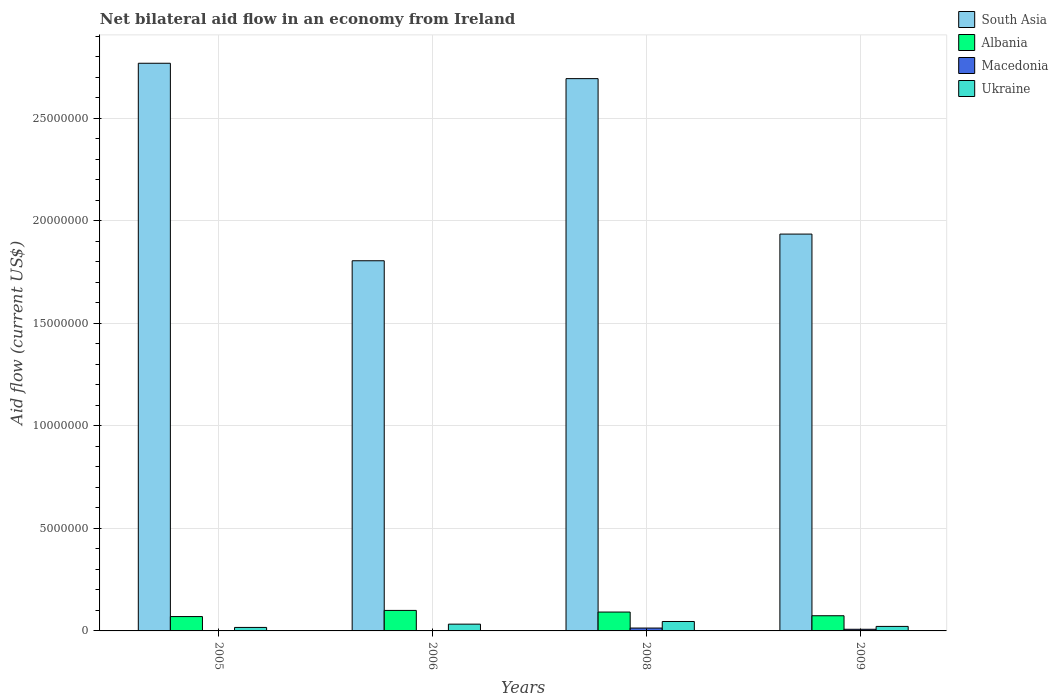Are the number of bars on each tick of the X-axis equal?
Offer a terse response. Yes. How many bars are there on the 4th tick from the left?
Your answer should be compact. 4. In how many cases, is the number of bars for a given year not equal to the number of legend labels?
Make the answer very short. 0. What is the net bilateral aid flow in Albania in 2009?
Offer a very short reply. 7.40e+05. Across all years, what is the maximum net bilateral aid flow in Ukraine?
Your response must be concise. 4.60e+05. In which year was the net bilateral aid flow in Albania maximum?
Ensure brevity in your answer.  2006. What is the total net bilateral aid flow in Albania in the graph?
Offer a very short reply. 3.36e+06. What is the difference between the net bilateral aid flow in South Asia in 2005 and the net bilateral aid flow in Albania in 2009?
Make the answer very short. 2.69e+07. What is the average net bilateral aid flow in Albania per year?
Keep it short and to the point. 8.40e+05. In the year 2008, what is the difference between the net bilateral aid flow in South Asia and net bilateral aid flow in Ukraine?
Offer a terse response. 2.65e+07. What is the ratio of the net bilateral aid flow in Ukraine in 2006 to that in 2008?
Give a very brief answer. 0.72. Is the difference between the net bilateral aid flow in South Asia in 2005 and 2008 greater than the difference between the net bilateral aid flow in Ukraine in 2005 and 2008?
Offer a terse response. Yes. What is the difference between the highest and the second highest net bilateral aid flow in Ukraine?
Make the answer very short. 1.30e+05. In how many years, is the net bilateral aid flow in Ukraine greater than the average net bilateral aid flow in Ukraine taken over all years?
Your response must be concise. 2. Is the sum of the net bilateral aid flow in Albania in 2005 and 2006 greater than the maximum net bilateral aid flow in Ukraine across all years?
Your response must be concise. Yes. What does the 1st bar from the left in 2006 represents?
Your response must be concise. South Asia. What does the 2nd bar from the right in 2005 represents?
Your answer should be compact. Macedonia. How many bars are there?
Offer a terse response. 16. Are all the bars in the graph horizontal?
Ensure brevity in your answer.  No. How many years are there in the graph?
Provide a short and direct response. 4. What is the difference between two consecutive major ticks on the Y-axis?
Offer a terse response. 5.00e+06. Are the values on the major ticks of Y-axis written in scientific E-notation?
Keep it short and to the point. No. Does the graph contain grids?
Ensure brevity in your answer.  Yes. Where does the legend appear in the graph?
Offer a very short reply. Top right. How many legend labels are there?
Your answer should be compact. 4. What is the title of the graph?
Provide a succinct answer. Net bilateral aid flow in an economy from Ireland. What is the Aid flow (current US$) of South Asia in 2005?
Your answer should be compact. 2.77e+07. What is the Aid flow (current US$) of Ukraine in 2005?
Keep it short and to the point. 1.70e+05. What is the Aid flow (current US$) of South Asia in 2006?
Your answer should be compact. 1.80e+07. What is the Aid flow (current US$) in Ukraine in 2006?
Ensure brevity in your answer.  3.30e+05. What is the Aid flow (current US$) in South Asia in 2008?
Your answer should be very brief. 2.69e+07. What is the Aid flow (current US$) in Albania in 2008?
Your answer should be compact. 9.20e+05. What is the Aid flow (current US$) in South Asia in 2009?
Offer a terse response. 1.94e+07. What is the Aid flow (current US$) of Albania in 2009?
Offer a terse response. 7.40e+05. Across all years, what is the maximum Aid flow (current US$) in South Asia?
Offer a very short reply. 2.77e+07. Across all years, what is the maximum Aid flow (current US$) in Albania?
Make the answer very short. 1.00e+06. Across all years, what is the maximum Aid flow (current US$) in Macedonia?
Keep it short and to the point. 1.40e+05. Across all years, what is the maximum Aid flow (current US$) in Ukraine?
Offer a terse response. 4.60e+05. Across all years, what is the minimum Aid flow (current US$) in South Asia?
Your response must be concise. 1.80e+07. Across all years, what is the minimum Aid flow (current US$) in Ukraine?
Keep it short and to the point. 1.70e+05. What is the total Aid flow (current US$) of South Asia in the graph?
Give a very brief answer. 9.20e+07. What is the total Aid flow (current US$) in Albania in the graph?
Offer a very short reply. 3.36e+06. What is the total Aid flow (current US$) of Ukraine in the graph?
Provide a succinct answer. 1.18e+06. What is the difference between the Aid flow (current US$) of South Asia in 2005 and that in 2006?
Ensure brevity in your answer.  9.63e+06. What is the difference between the Aid flow (current US$) of Albania in 2005 and that in 2006?
Your response must be concise. -3.00e+05. What is the difference between the Aid flow (current US$) of Macedonia in 2005 and that in 2006?
Your answer should be compact. -10000. What is the difference between the Aid flow (current US$) of Ukraine in 2005 and that in 2006?
Offer a very short reply. -1.60e+05. What is the difference between the Aid flow (current US$) of South Asia in 2005 and that in 2008?
Your answer should be very brief. 7.50e+05. What is the difference between the Aid flow (current US$) in Macedonia in 2005 and that in 2008?
Your answer should be very brief. -1.30e+05. What is the difference between the Aid flow (current US$) of South Asia in 2005 and that in 2009?
Keep it short and to the point. 8.33e+06. What is the difference between the Aid flow (current US$) in Macedonia in 2005 and that in 2009?
Your answer should be compact. -7.00e+04. What is the difference between the Aid flow (current US$) of South Asia in 2006 and that in 2008?
Your answer should be compact. -8.88e+06. What is the difference between the Aid flow (current US$) in Albania in 2006 and that in 2008?
Provide a short and direct response. 8.00e+04. What is the difference between the Aid flow (current US$) in Ukraine in 2006 and that in 2008?
Offer a terse response. -1.30e+05. What is the difference between the Aid flow (current US$) of South Asia in 2006 and that in 2009?
Provide a succinct answer. -1.30e+06. What is the difference between the Aid flow (current US$) in Albania in 2006 and that in 2009?
Provide a succinct answer. 2.60e+05. What is the difference between the Aid flow (current US$) in Macedonia in 2006 and that in 2009?
Give a very brief answer. -6.00e+04. What is the difference between the Aid flow (current US$) in Ukraine in 2006 and that in 2009?
Keep it short and to the point. 1.10e+05. What is the difference between the Aid flow (current US$) of South Asia in 2008 and that in 2009?
Ensure brevity in your answer.  7.58e+06. What is the difference between the Aid flow (current US$) in Albania in 2008 and that in 2009?
Keep it short and to the point. 1.80e+05. What is the difference between the Aid flow (current US$) in Macedonia in 2008 and that in 2009?
Offer a terse response. 6.00e+04. What is the difference between the Aid flow (current US$) in Ukraine in 2008 and that in 2009?
Offer a very short reply. 2.40e+05. What is the difference between the Aid flow (current US$) in South Asia in 2005 and the Aid flow (current US$) in Albania in 2006?
Your answer should be compact. 2.67e+07. What is the difference between the Aid flow (current US$) in South Asia in 2005 and the Aid flow (current US$) in Macedonia in 2006?
Provide a succinct answer. 2.77e+07. What is the difference between the Aid flow (current US$) of South Asia in 2005 and the Aid flow (current US$) of Ukraine in 2006?
Your answer should be compact. 2.74e+07. What is the difference between the Aid flow (current US$) of Albania in 2005 and the Aid flow (current US$) of Macedonia in 2006?
Keep it short and to the point. 6.80e+05. What is the difference between the Aid flow (current US$) in Macedonia in 2005 and the Aid flow (current US$) in Ukraine in 2006?
Provide a short and direct response. -3.20e+05. What is the difference between the Aid flow (current US$) of South Asia in 2005 and the Aid flow (current US$) of Albania in 2008?
Keep it short and to the point. 2.68e+07. What is the difference between the Aid flow (current US$) in South Asia in 2005 and the Aid flow (current US$) in Macedonia in 2008?
Ensure brevity in your answer.  2.75e+07. What is the difference between the Aid flow (current US$) in South Asia in 2005 and the Aid flow (current US$) in Ukraine in 2008?
Your answer should be very brief. 2.72e+07. What is the difference between the Aid flow (current US$) of Albania in 2005 and the Aid flow (current US$) of Macedonia in 2008?
Make the answer very short. 5.60e+05. What is the difference between the Aid flow (current US$) of Macedonia in 2005 and the Aid flow (current US$) of Ukraine in 2008?
Your answer should be very brief. -4.50e+05. What is the difference between the Aid flow (current US$) of South Asia in 2005 and the Aid flow (current US$) of Albania in 2009?
Keep it short and to the point. 2.69e+07. What is the difference between the Aid flow (current US$) in South Asia in 2005 and the Aid flow (current US$) in Macedonia in 2009?
Your response must be concise. 2.76e+07. What is the difference between the Aid flow (current US$) in South Asia in 2005 and the Aid flow (current US$) in Ukraine in 2009?
Your answer should be compact. 2.75e+07. What is the difference between the Aid flow (current US$) in Albania in 2005 and the Aid flow (current US$) in Macedonia in 2009?
Make the answer very short. 6.20e+05. What is the difference between the Aid flow (current US$) in Albania in 2005 and the Aid flow (current US$) in Ukraine in 2009?
Make the answer very short. 4.80e+05. What is the difference between the Aid flow (current US$) of Macedonia in 2005 and the Aid flow (current US$) of Ukraine in 2009?
Provide a short and direct response. -2.10e+05. What is the difference between the Aid flow (current US$) in South Asia in 2006 and the Aid flow (current US$) in Albania in 2008?
Give a very brief answer. 1.71e+07. What is the difference between the Aid flow (current US$) of South Asia in 2006 and the Aid flow (current US$) of Macedonia in 2008?
Keep it short and to the point. 1.79e+07. What is the difference between the Aid flow (current US$) in South Asia in 2006 and the Aid flow (current US$) in Ukraine in 2008?
Ensure brevity in your answer.  1.76e+07. What is the difference between the Aid flow (current US$) of Albania in 2006 and the Aid flow (current US$) of Macedonia in 2008?
Keep it short and to the point. 8.60e+05. What is the difference between the Aid flow (current US$) of Albania in 2006 and the Aid flow (current US$) of Ukraine in 2008?
Your answer should be compact. 5.40e+05. What is the difference between the Aid flow (current US$) of Macedonia in 2006 and the Aid flow (current US$) of Ukraine in 2008?
Offer a terse response. -4.40e+05. What is the difference between the Aid flow (current US$) of South Asia in 2006 and the Aid flow (current US$) of Albania in 2009?
Your answer should be compact. 1.73e+07. What is the difference between the Aid flow (current US$) in South Asia in 2006 and the Aid flow (current US$) in Macedonia in 2009?
Offer a terse response. 1.80e+07. What is the difference between the Aid flow (current US$) of South Asia in 2006 and the Aid flow (current US$) of Ukraine in 2009?
Give a very brief answer. 1.78e+07. What is the difference between the Aid flow (current US$) in Albania in 2006 and the Aid flow (current US$) in Macedonia in 2009?
Make the answer very short. 9.20e+05. What is the difference between the Aid flow (current US$) in Albania in 2006 and the Aid flow (current US$) in Ukraine in 2009?
Keep it short and to the point. 7.80e+05. What is the difference between the Aid flow (current US$) in South Asia in 2008 and the Aid flow (current US$) in Albania in 2009?
Give a very brief answer. 2.62e+07. What is the difference between the Aid flow (current US$) in South Asia in 2008 and the Aid flow (current US$) in Macedonia in 2009?
Ensure brevity in your answer.  2.68e+07. What is the difference between the Aid flow (current US$) in South Asia in 2008 and the Aid flow (current US$) in Ukraine in 2009?
Provide a succinct answer. 2.67e+07. What is the difference between the Aid flow (current US$) of Albania in 2008 and the Aid flow (current US$) of Macedonia in 2009?
Your answer should be compact. 8.40e+05. What is the difference between the Aid flow (current US$) of Macedonia in 2008 and the Aid flow (current US$) of Ukraine in 2009?
Provide a short and direct response. -8.00e+04. What is the average Aid flow (current US$) in South Asia per year?
Your answer should be very brief. 2.30e+07. What is the average Aid flow (current US$) in Albania per year?
Make the answer very short. 8.40e+05. What is the average Aid flow (current US$) in Macedonia per year?
Your answer should be very brief. 6.25e+04. What is the average Aid flow (current US$) in Ukraine per year?
Offer a terse response. 2.95e+05. In the year 2005, what is the difference between the Aid flow (current US$) in South Asia and Aid flow (current US$) in Albania?
Your response must be concise. 2.70e+07. In the year 2005, what is the difference between the Aid flow (current US$) of South Asia and Aid flow (current US$) of Macedonia?
Keep it short and to the point. 2.77e+07. In the year 2005, what is the difference between the Aid flow (current US$) of South Asia and Aid flow (current US$) of Ukraine?
Offer a terse response. 2.75e+07. In the year 2005, what is the difference between the Aid flow (current US$) in Albania and Aid flow (current US$) in Macedonia?
Your answer should be compact. 6.90e+05. In the year 2005, what is the difference between the Aid flow (current US$) in Albania and Aid flow (current US$) in Ukraine?
Offer a terse response. 5.30e+05. In the year 2005, what is the difference between the Aid flow (current US$) in Macedonia and Aid flow (current US$) in Ukraine?
Give a very brief answer. -1.60e+05. In the year 2006, what is the difference between the Aid flow (current US$) in South Asia and Aid flow (current US$) in Albania?
Provide a succinct answer. 1.70e+07. In the year 2006, what is the difference between the Aid flow (current US$) in South Asia and Aid flow (current US$) in Macedonia?
Keep it short and to the point. 1.80e+07. In the year 2006, what is the difference between the Aid flow (current US$) of South Asia and Aid flow (current US$) of Ukraine?
Offer a very short reply. 1.77e+07. In the year 2006, what is the difference between the Aid flow (current US$) in Albania and Aid flow (current US$) in Macedonia?
Provide a short and direct response. 9.80e+05. In the year 2006, what is the difference between the Aid flow (current US$) of Albania and Aid flow (current US$) of Ukraine?
Provide a short and direct response. 6.70e+05. In the year 2006, what is the difference between the Aid flow (current US$) in Macedonia and Aid flow (current US$) in Ukraine?
Make the answer very short. -3.10e+05. In the year 2008, what is the difference between the Aid flow (current US$) in South Asia and Aid flow (current US$) in Albania?
Your answer should be very brief. 2.60e+07. In the year 2008, what is the difference between the Aid flow (current US$) in South Asia and Aid flow (current US$) in Macedonia?
Ensure brevity in your answer.  2.68e+07. In the year 2008, what is the difference between the Aid flow (current US$) of South Asia and Aid flow (current US$) of Ukraine?
Give a very brief answer. 2.65e+07. In the year 2008, what is the difference between the Aid flow (current US$) in Albania and Aid flow (current US$) in Macedonia?
Offer a very short reply. 7.80e+05. In the year 2008, what is the difference between the Aid flow (current US$) in Macedonia and Aid flow (current US$) in Ukraine?
Provide a short and direct response. -3.20e+05. In the year 2009, what is the difference between the Aid flow (current US$) of South Asia and Aid flow (current US$) of Albania?
Your response must be concise. 1.86e+07. In the year 2009, what is the difference between the Aid flow (current US$) in South Asia and Aid flow (current US$) in Macedonia?
Your answer should be very brief. 1.93e+07. In the year 2009, what is the difference between the Aid flow (current US$) of South Asia and Aid flow (current US$) of Ukraine?
Provide a succinct answer. 1.91e+07. In the year 2009, what is the difference between the Aid flow (current US$) in Albania and Aid flow (current US$) in Ukraine?
Make the answer very short. 5.20e+05. In the year 2009, what is the difference between the Aid flow (current US$) in Macedonia and Aid flow (current US$) in Ukraine?
Provide a succinct answer. -1.40e+05. What is the ratio of the Aid flow (current US$) in South Asia in 2005 to that in 2006?
Offer a very short reply. 1.53. What is the ratio of the Aid flow (current US$) in Albania in 2005 to that in 2006?
Keep it short and to the point. 0.7. What is the ratio of the Aid flow (current US$) in Ukraine in 2005 to that in 2006?
Give a very brief answer. 0.52. What is the ratio of the Aid flow (current US$) in South Asia in 2005 to that in 2008?
Give a very brief answer. 1.03. What is the ratio of the Aid flow (current US$) in Albania in 2005 to that in 2008?
Your answer should be very brief. 0.76. What is the ratio of the Aid flow (current US$) in Macedonia in 2005 to that in 2008?
Ensure brevity in your answer.  0.07. What is the ratio of the Aid flow (current US$) in Ukraine in 2005 to that in 2008?
Provide a succinct answer. 0.37. What is the ratio of the Aid flow (current US$) of South Asia in 2005 to that in 2009?
Offer a terse response. 1.43. What is the ratio of the Aid flow (current US$) of Albania in 2005 to that in 2009?
Make the answer very short. 0.95. What is the ratio of the Aid flow (current US$) in Ukraine in 2005 to that in 2009?
Offer a terse response. 0.77. What is the ratio of the Aid flow (current US$) of South Asia in 2006 to that in 2008?
Give a very brief answer. 0.67. What is the ratio of the Aid flow (current US$) in Albania in 2006 to that in 2008?
Your answer should be compact. 1.09. What is the ratio of the Aid flow (current US$) of Macedonia in 2006 to that in 2008?
Provide a succinct answer. 0.14. What is the ratio of the Aid flow (current US$) of Ukraine in 2006 to that in 2008?
Provide a short and direct response. 0.72. What is the ratio of the Aid flow (current US$) in South Asia in 2006 to that in 2009?
Your answer should be very brief. 0.93. What is the ratio of the Aid flow (current US$) in Albania in 2006 to that in 2009?
Give a very brief answer. 1.35. What is the ratio of the Aid flow (current US$) of Macedonia in 2006 to that in 2009?
Make the answer very short. 0.25. What is the ratio of the Aid flow (current US$) of Ukraine in 2006 to that in 2009?
Keep it short and to the point. 1.5. What is the ratio of the Aid flow (current US$) of South Asia in 2008 to that in 2009?
Your response must be concise. 1.39. What is the ratio of the Aid flow (current US$) in Albania in 2008 to that in 2009?
Offer a very short reply. 1.24. What is the ratio of the Aid flow (current US$) in Ukraine in 2008 to that in 2009?
Provide a short and direct response. 2.09. What is the difference between the highest and the second highest Aid flow (current US$) in South Asia?
Keep it short and to the point. 7.50e+05. What is the difference between the highest and the second highest Aid flow (current US$) of Macedonia?
Ensure brevity in your answer.  6.00e+04. What is the difference between the highest and the second highest Aid flow (current US$) in Ukraine?
Your answer should be very brief. 1.30e+05. What is the difference between the highest and the lowest Aid flow (current US$) of South Asia?
Give a very brief answer. 9.63e+06. What is the difference between the highest and the lowest Aid flow (current US$) in Albania?
Ensure brevity in your answer.  3.00e+05. What is the difference between the highest and the lowest Aid flow (current US$) of Macedonia?
Provide a succinct answer. 1.30e+05. 